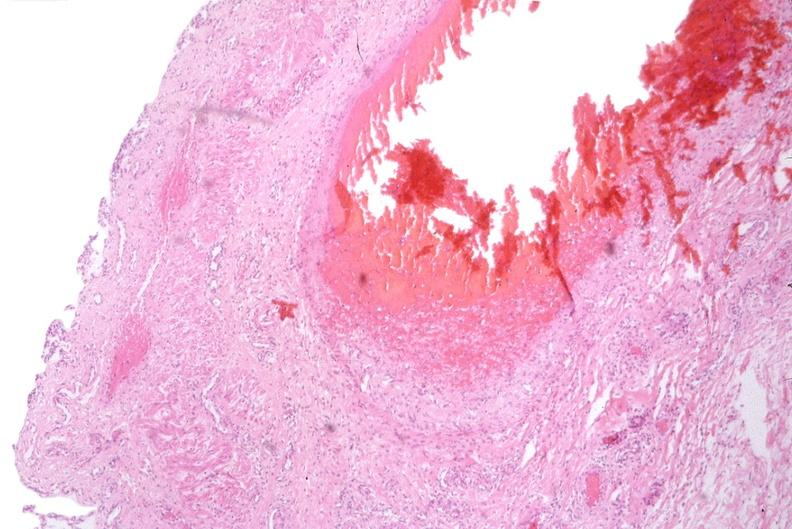does dysplastic show esophogus, varices due to portal hypertension from cirrhosis, hcv?
Answer the question using a single word or phrase. No 